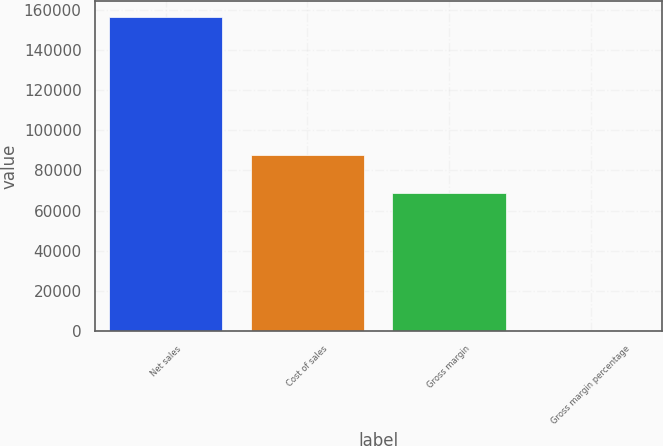Convert chart to OTSL. <chart><loc_0><loc_0><loc_500><loc_500><bar_chart><fcel>Net sales<fcel>Cost of sales<fcel>Gross margin<fcel>Gross margin percentage<nl><fcel>156508<fcel>87846<fcel>68662<fcel>43.9<nl></chart> 